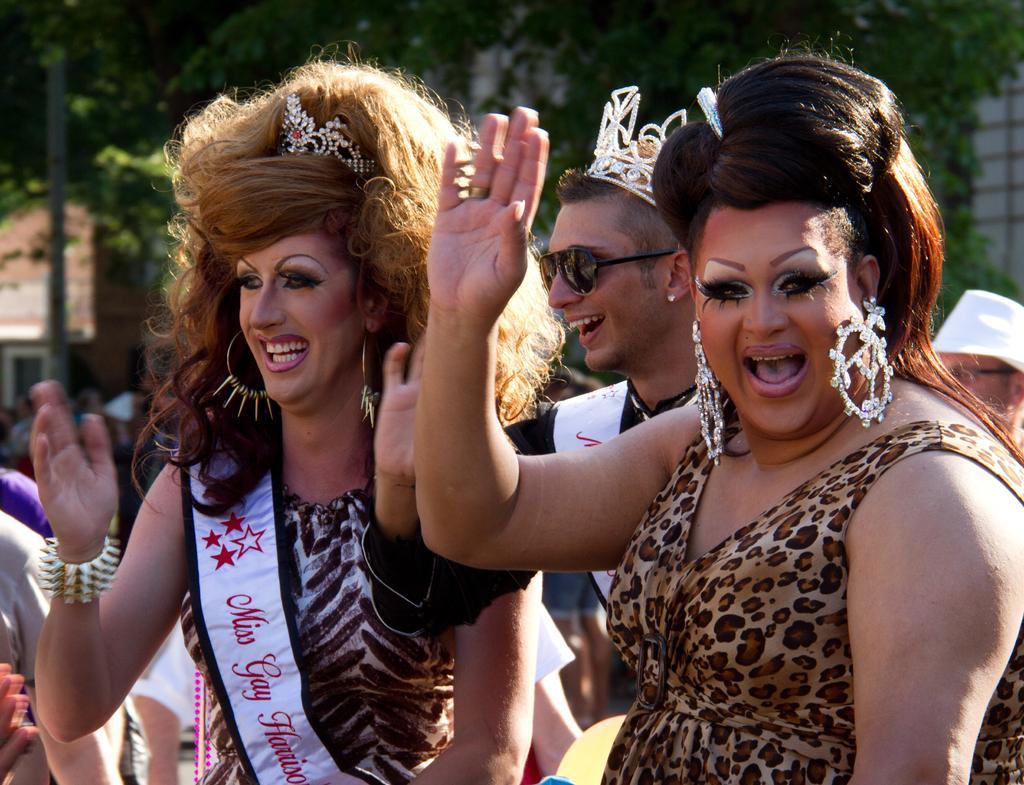Describe this image in one or two sentences. This picture is clicked outside. In the foreground we can see the two women wearing dresses, smiling and seems to be standing. In the background we can see the group of persons, trees, metal rod and many other objects. 